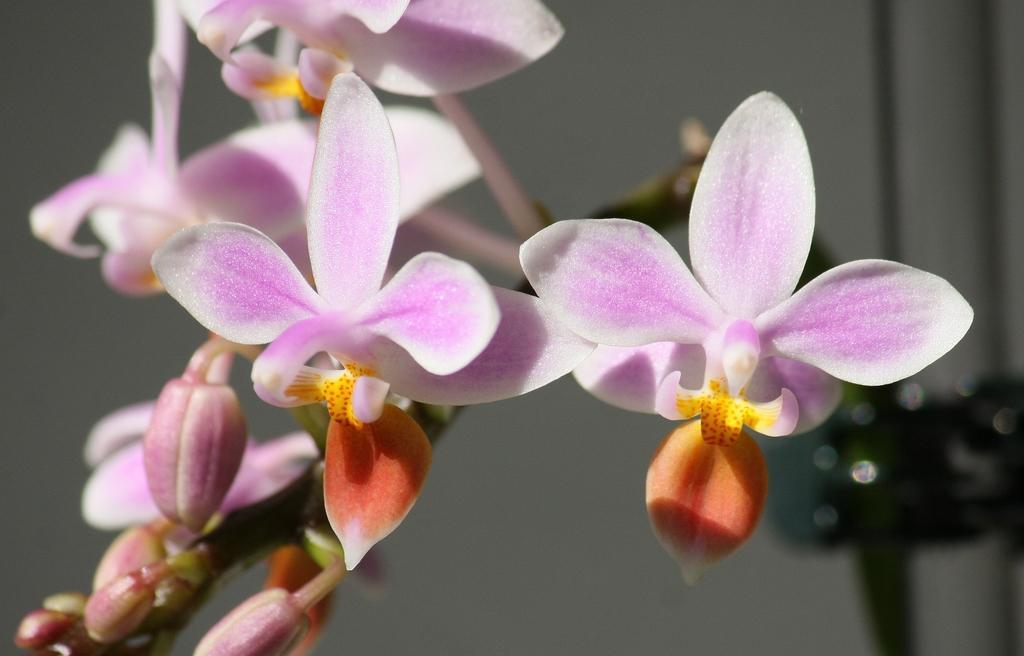Can you describe this image briefly? This is a zoomed in picture. In the foreground we can see the flowers and buds. In the background there are some other objects. 